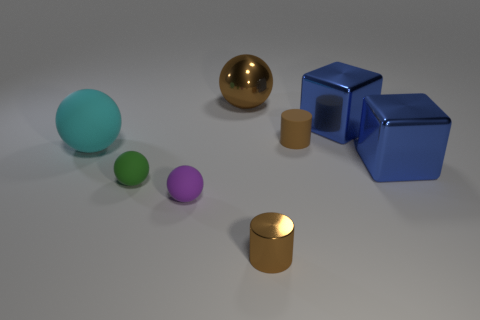Can you describe the arrangement of the shapes seen in the image? In the image, there is an assortment of geometric shapes arranged on a flat surface. From left to right, we see a large aqua sphere, a small green sphere, a small purple sphere, a large gold sphere, two connected blue cubes, and a small blue cube. In the foreground, there is a small tan cylinder and a larger matching cylinder behind it. 